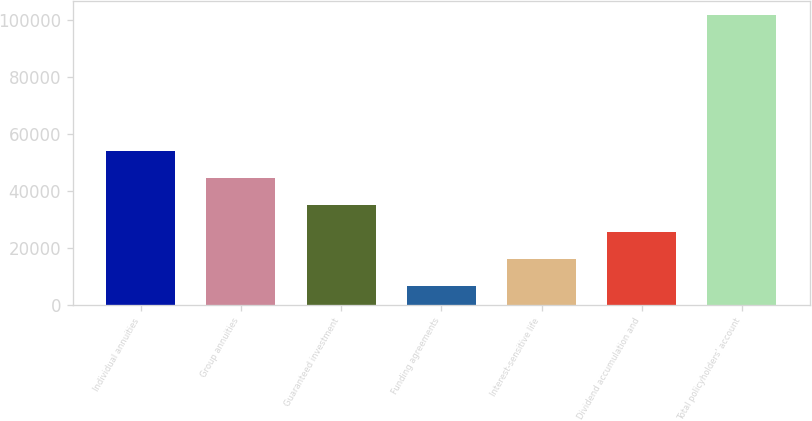<chart> <loc_0><loc_0><loc_500><loc_500><bar_chart><fcel>Individual annuities<fcel>Group annuities<fcel>Guaranteed investment<fcel>Funding agreements<fcel>Interest-sensitive life<fcel>Dividend accumulation and<fcel>Total policyholders' account<nl><fcel>54123.5<fcel>44615<fcel>35106.5<fcel>6581<fcel>16089.5<fcel>25598<fcel>101666<nl></chart> 